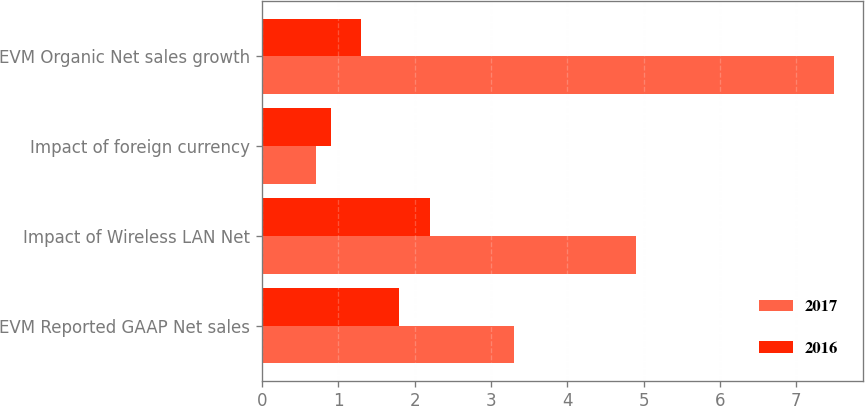Convert chart to OTSL. <chart><loc_0><loc_0><loc_500><loc_500><stacked_bar_chart><ecel><fcel>EVM Reported GAAP Net sales<fcel>Impact of Wireless LAN Net<fcel>Impact of foreign currency<fcel>EVM Organic Net sales growth<nl><fcel>2017<fcel>3.3<fcel>4.9<fcel>0.7<fcel>7.5<nl><fcel>2016<fcel>1.8<fcel>2.2<fcel>0.9<fcel>1.3<nl></chart> 